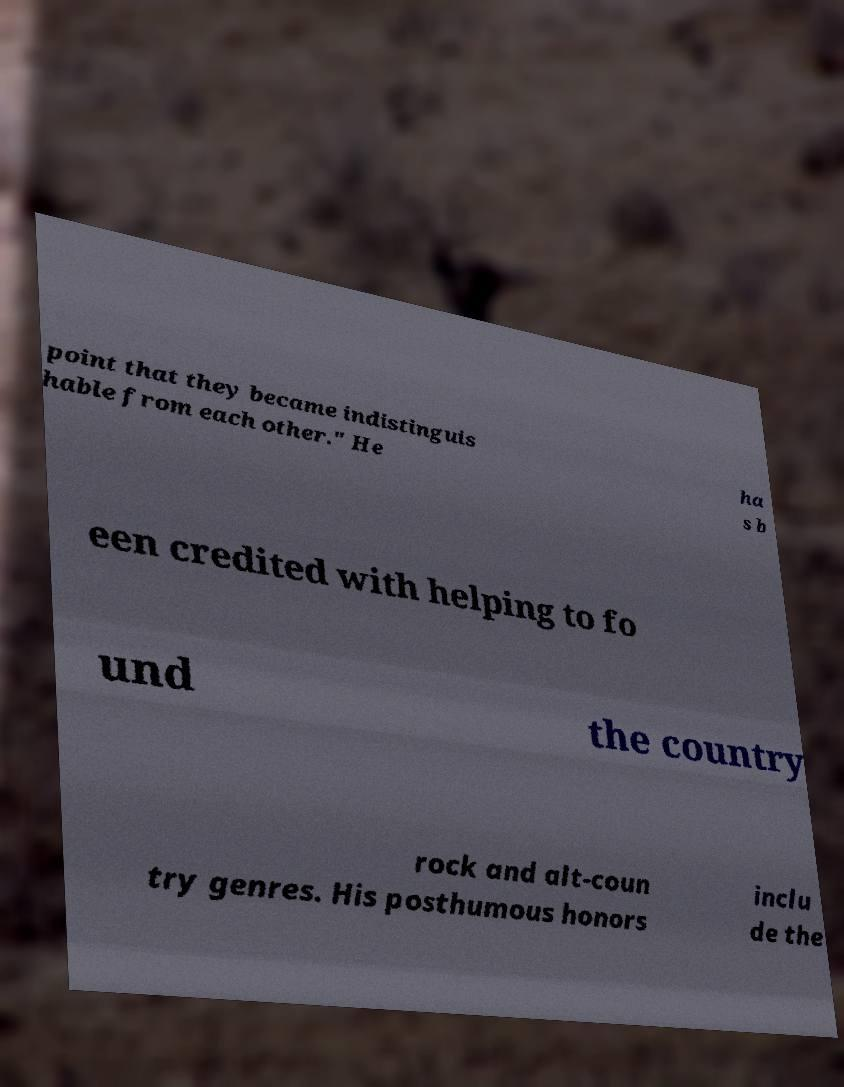For documentation purposes, I need the text within this image transcribed. Could you provide that? point that they became indistinguis hable from each other." He ha s b een credited with helping to fo und the country rock and alt-coun try genres. His posthumous honors inclu de the 